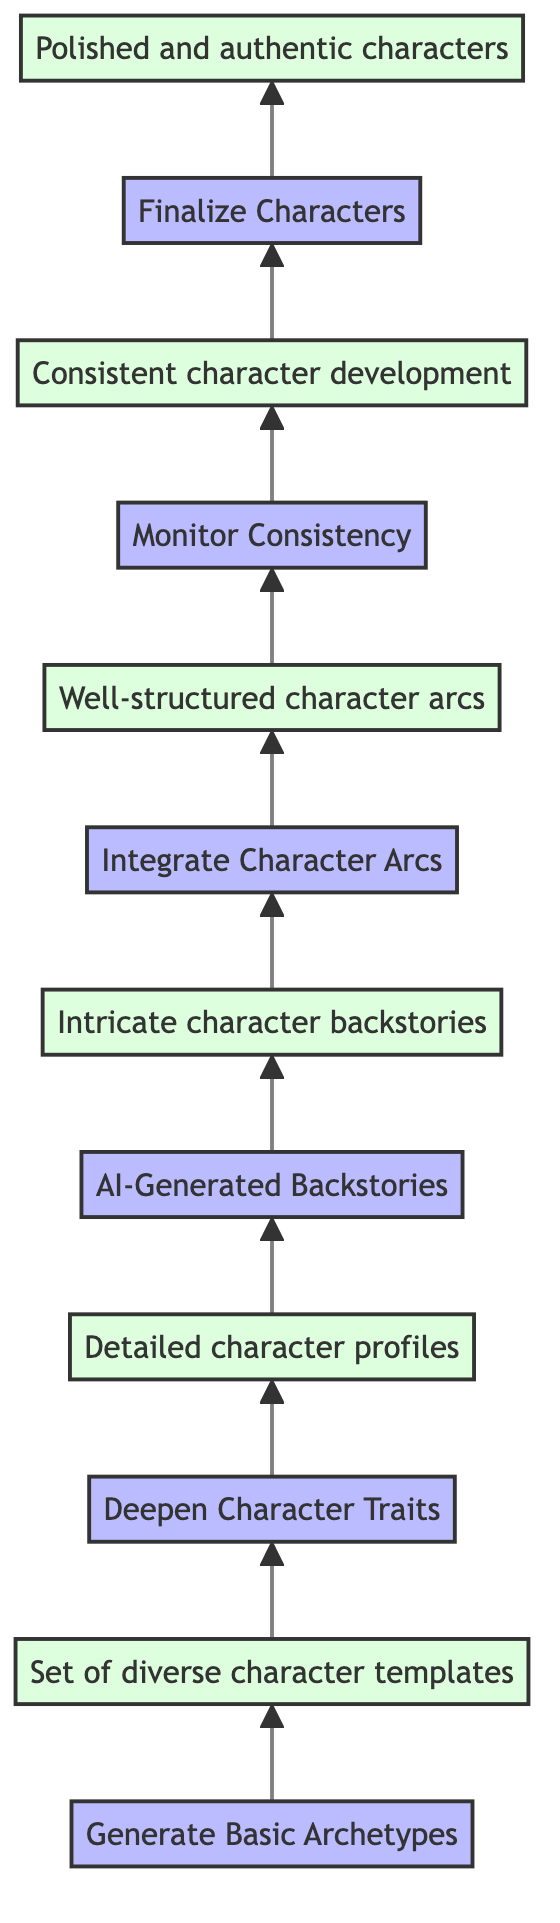What is the output of Step 1? The output of Step 1 is directly linked to that node and is specified as a "Set of diverse character templates."
Answer: Set of diverse character templates How many steps are in the workflow? By counting the individual steps from "Generate Basic Archetypes" to "Finalize Characters," there are a total of 6 steps in the workflow.
Answer: 6 Which step comes after Deepen Character Traits? Following Deepen Character Traits, the next step in the workflow is AI-Generated Backstories, as indicated by the direct arrow leading from the former to the latter.
Answer: AI-Generated Backstories What is the purpose of monitoring consistency? The purpose of monitoring consistency is to ensure "Consistent character development," as shown in the output of the respective step in the diagram.
Answer: Consistent character development What tools are used in Step 4? The tools used in Step 4, which are responsible for integrating character arcs, are "Story Arc Algorithms" and "Plot Progression Models," listed under that step.
Answer: Story Arc Algorithms, Plot Progression Models What is the final output of the workflow? The final output of the workflow, reached after all preceding steps, is "Polished and authentic characters." This output concludes the entire development process shown in the diagram.
Answer: Polished and authentic characters In which step is AI utilized to enhance character profiles? AI is utilized to enhance character profiles in Step 2, titled "Deepen Character Traits," where detailed profiles are generated.
Answer: Deepen Character Traits How is the character arc output described? The output of the character arc integration is described as "Well-structured character arcs fitting the narrative," detailing the result of the respective workflow step.
Answer: Well-structured character arcs fitting the narrative 